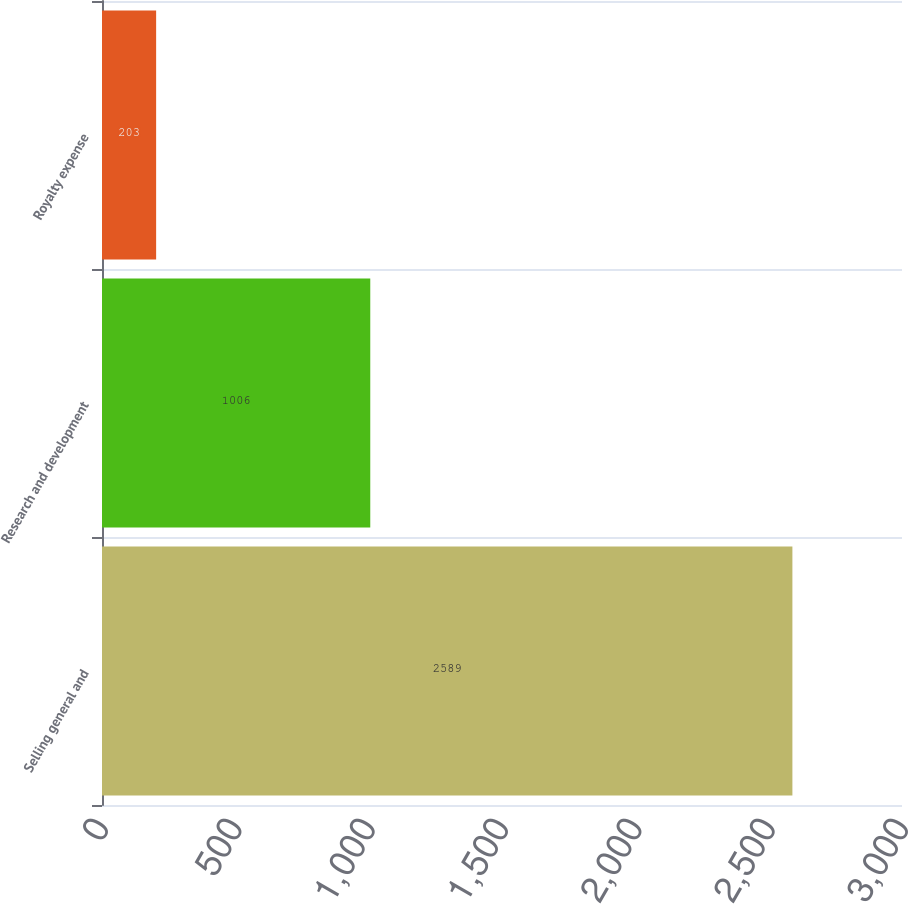Convert chart to OTSL. <chart><loc_0><loc_0><loc_500><loc_500><bar_chart><fcel>Selling general and<fcel>Research and development<fcel>Royalty expense<nl><fcel>2589<fcel>1006<fcel>203<nl></chart> 